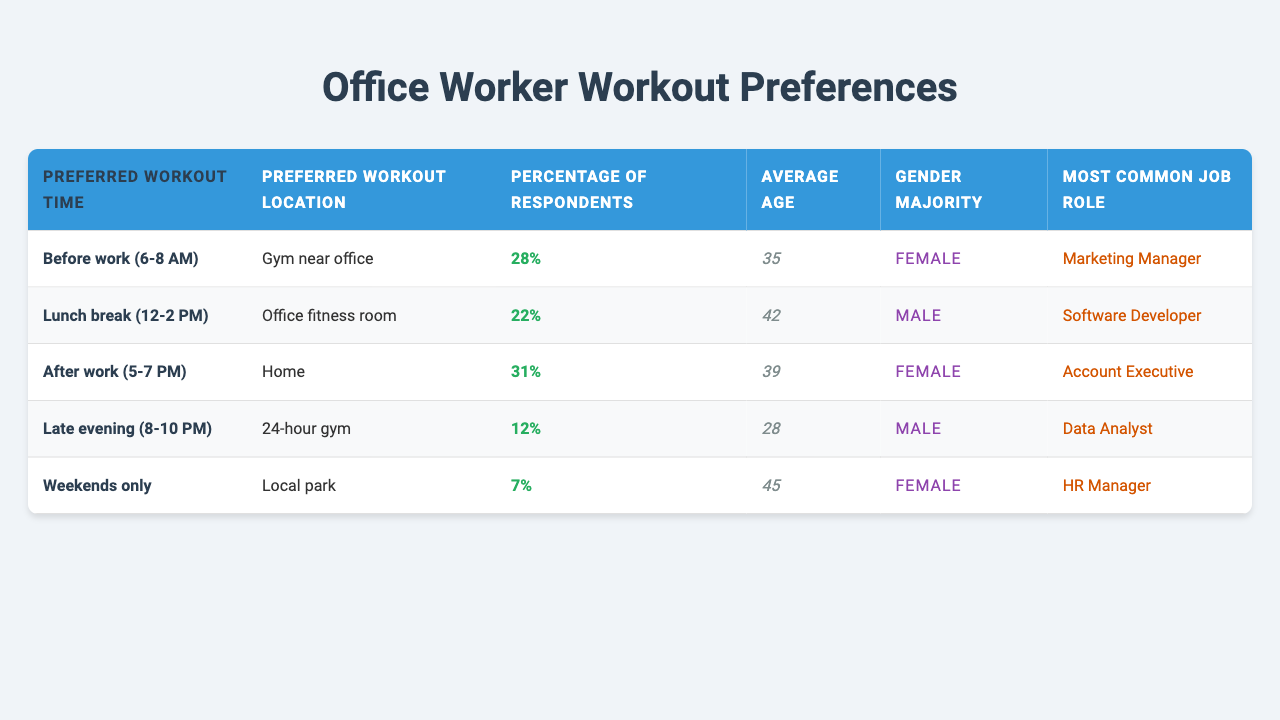What's the preferred workout time for the largest percentage of respondents? The highest percentage listed in the table is 31%, corresponding to the workout time "After work (5-7 PM)."
Answer: After work (5-7 PM) What is the average age of respondents who prefer working out during their lunch break? Referring to the table, the average age for the "Lunch break (12-2 PM)" category is 42.
Answer: 42 Which gender is the majority among those who prefer to work out before work? The table indicates that the gender majority for the "Before work (6-8 AM)" category is Female.
Answer: Female What percentage of respondents prefers to work out on weekends only? The table reports that 7% of respondents prefer the "Weekends only" workout time.
Answer: 7% What is the most common job role among respondents who prefer working out after work? According to the table, the most common job role for "After work (5-7 PM)" workouts is Account Executive.
Answer: Account Executive How does the preferred workout location vary with preferred workout times? The preferred locations for various workout times include: "Gym near office" for before work, "Office fitness room" for lunch, "Home" for after work, "24-hour gym" for late evening, and "Local park" for weekends.
Answer: Varies by time Which workout time has the least interest among respondents? The workout time "Weekends only" has the least interest, with only 7% of respondents preferring it.
Answer: Weekends only Is there a significant age difference between those who prefer to work out after work and those who prefer to work out before work? Yes, the average age for "After work (5-7 PM)" is 39, while for "Before work (6-8 AM)" it's 35, which shows a 4-year difference.
Answer: Yes What is the combined percentage of respondents who prefer to work out before work and after work? The percentages of respondents preferring "Before work (6-8 AM)" (28%) and "After work (5-7 PM)" (31%) add up to 59%.
Answer: 59% Is the gender majority consistent across all workout times? No, the gender majority varies; Females dominate before work and after work, while Males are the majority during lunch and late evening workouts.
Answer: No What proportion of respondents prefers a location other than a gym for their workouts? The "Home" and "Local park" locations are outside gym settings, totaling 38% (31% for home and 7% for local park).
Answer: 38% 